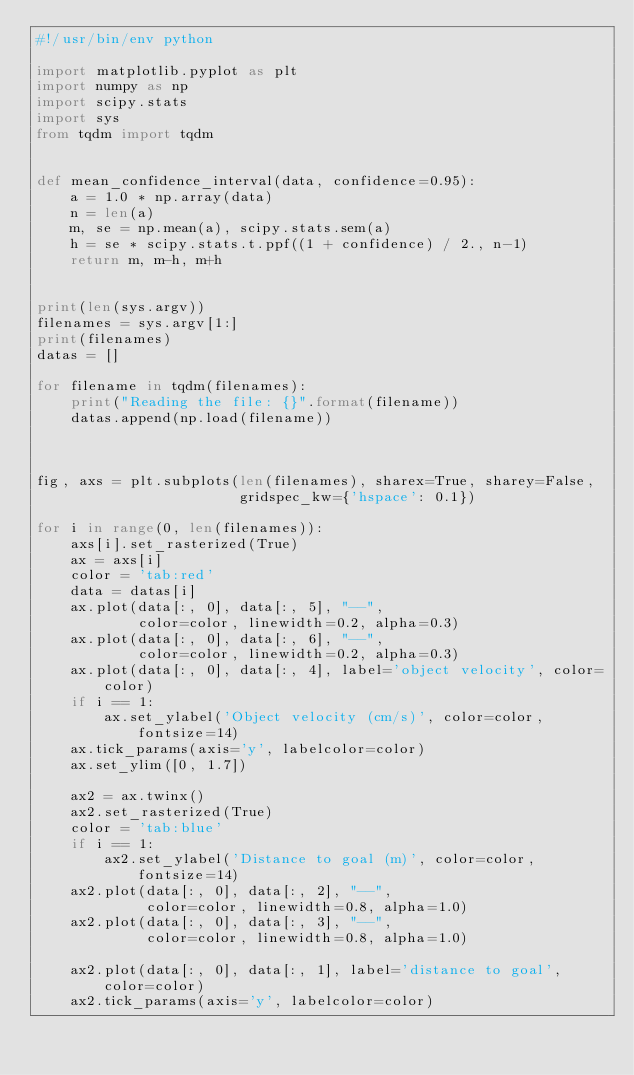<code> <loc_0><loc_0><loc_500><loc_500><_Python_>#!/usr/bin/env python

import matplotlib.pyplot as plt
import numpy as np
import scipy.stats
import sys
from tqdm import tqdm 


def mean_confidence_interval(data, confidence=0.95):
    a = 1.0 * np.array(data)
    n = len(a)
    m, se = np.mean(a), scipy.stats.sem(a)
    h = se * scipy.stats.t.ppf((1 + confidence) / 2., n-1)
    return m, m-h, m+h


print(len(sys.argv))
filenames = sys.argv[1:]
print(filenames)
datas = []

for filename in tqdm(filenames):
    print("Reading the file: {}".format(filename))
    datas.append(np.load(filename))



fig, axs = plt.subplots(len(filenames), sharex=True, sharey=False,
                        gridspec_kw={'hspace': 0.1})

for i in range(0, len(filenames)):
    axs[i].set_rasterized(True)
    ax = axs[i]
    color = 'tab:red'
    data = datas[i]
    ax.plot(data[:, 0], data[:, 5], "--",
            color=color, linewidth=0.2, alpha=0.3)
    ax.plot(data[:, 0], data[:, 6], "--",
            color=color, linewidth=0.2, alpha=0.3)
    ax.plot(data[:, 0], data[:, 4], label='object velocity', color=color)
    if i == 1:
        ax.set_ylabel('Object velocity (cm/s)', color=color, fontsize=14)
    ax.tick_params(axis='y', labelcolor=color)
    ax.set_ylim([0, 1.7])

    ax2 = ax.twinx()
    ax2.set_rasterized(True)
    color = 'tab:blue'
    if i == 1:
        ax2.set_ylabel('Distance to goal (m)', color=color, fontsize=14)
    ax2.plot(data[:, 0], data[:, 2], "--",
             color=color, linewidth=0.8, alpha=1.0)
    ax2.plot(data[:, 0], data[:, 3], "--",
             color=color, linewidth=0.8, alpha=1.0)

    ax2.plot(data[:, 0], data[:, 1], label='distance to goal', color=color)
    ax2.tick_params(axis='y', labelcolor=color)</code> 